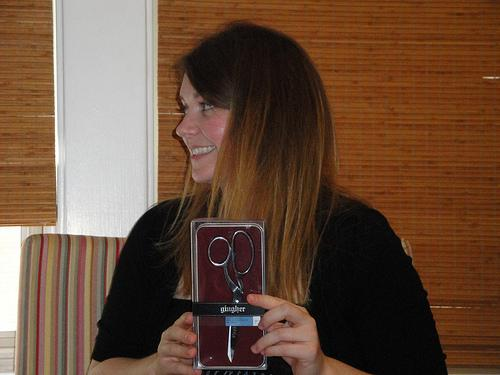Briefly talk about the main person in the image and what they are holding. A smiling woman is holding a case with scissors inside it. Describe the main person's hair and the shirt they are wearing in the image. The main person in the image is a woman with long hair, wearing a black shirt. Briefly describe the object that the woman is holding along with its appearance. The woman is holding a silver scissor inside an unopened case. Mention the object that the woman is interacting with and elaborate on its features. The woman is holding a box containing scissors with a silver handle in it. Provide a short description of the main female figure and her expression in the image. A smiling woman with long hair is the central figure in the image. Describe what the woman is doing and the appearance of the object she is holding. The woman is happily holding a case that contains silver scissors inside. Describe the woman's appearance and the object in her hands. A woman with long hair and a black shirt is holding a box containing silver scissors. Mention the hair color and clothing of the woman in the image, along with the object in her possession. The woman with long hair and black shirt is holding a case with silver scissors. Explain the appearance and action of the woman in this image. A woman with long hair and a beautiful smile is holding a pair of scissors in a case. 